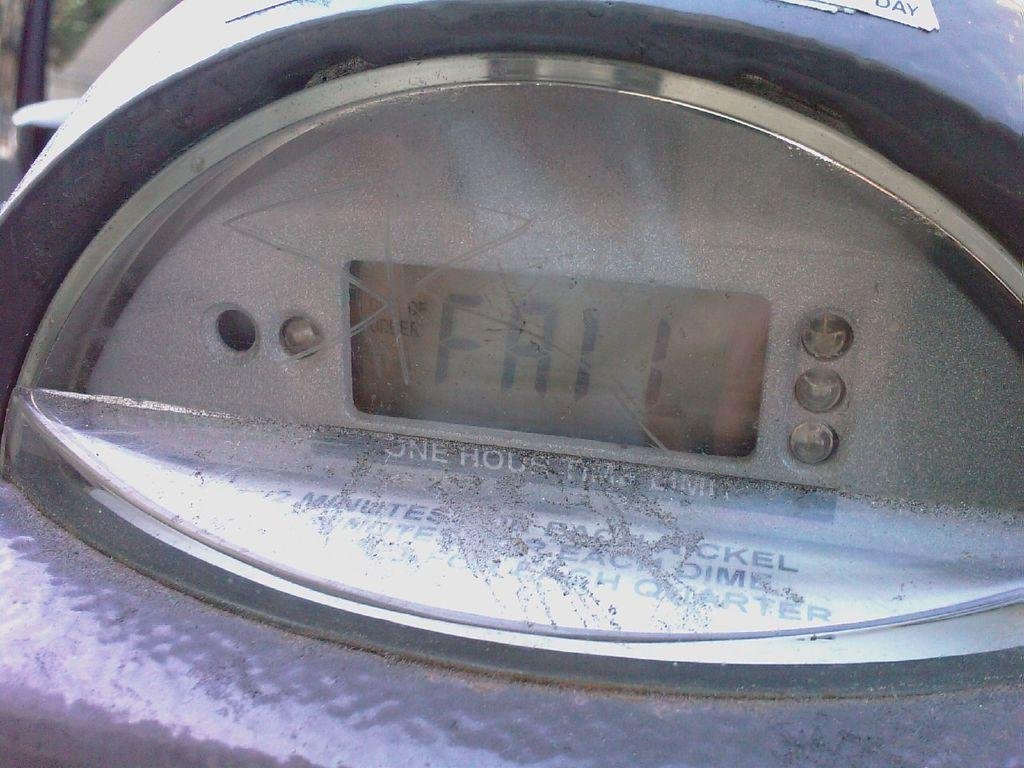<image>
Render a clear and concise summary of the photo. A digital screen shows the word fail on the screen. 